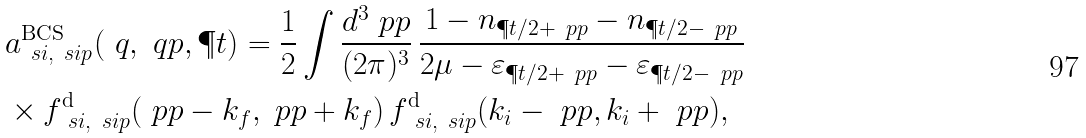Convert formula to latex. <formula><loc_0><loc_0><loc_500><loc_500>& a ^ { \text {BCS} } _ { \ s i , \ s i p } ( \ q , \ q p , \P t ) = \frac { 1 } { 2 } \int \frac { d ^ { 3 } \ p p } { ( 2 \pi ) ^ { 3 } } \, \frac { 1 - n _ { \P t / 2 + \ p p } - n _ { \P t / 2 - \ p p } } { 2 \mu - \varepsilon _ { \P t / 2 + \ p p } - \varepsilon _ { \P t / 2 - \ p p } } \\ & \times f ^ { \text {d} } _ { \ s i , \ s i p } ( \ p p - { k } _ { f } , \ p p + { k } _ { f } ) \, f ^ { \text {d} } _ { \ s i , \ s i p } ( { k } _ { i } - \ p p , { k } _ { i } + \ p p ) ,</formula> 